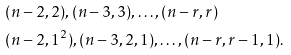Convert formula to latex. <formula><loc_0><loc_0><loc_500><loc_500>& ( n - 2 , 2 ) , ( n - 3 , 3 ) , \dots , ( n - r , r ) \\ & ( n - 2 , 1 ^ { 2 } ) , ( n - 3 , 2 , 1 ) , \dots , ( n - r , r - 1 , 1 ) .</formula> 